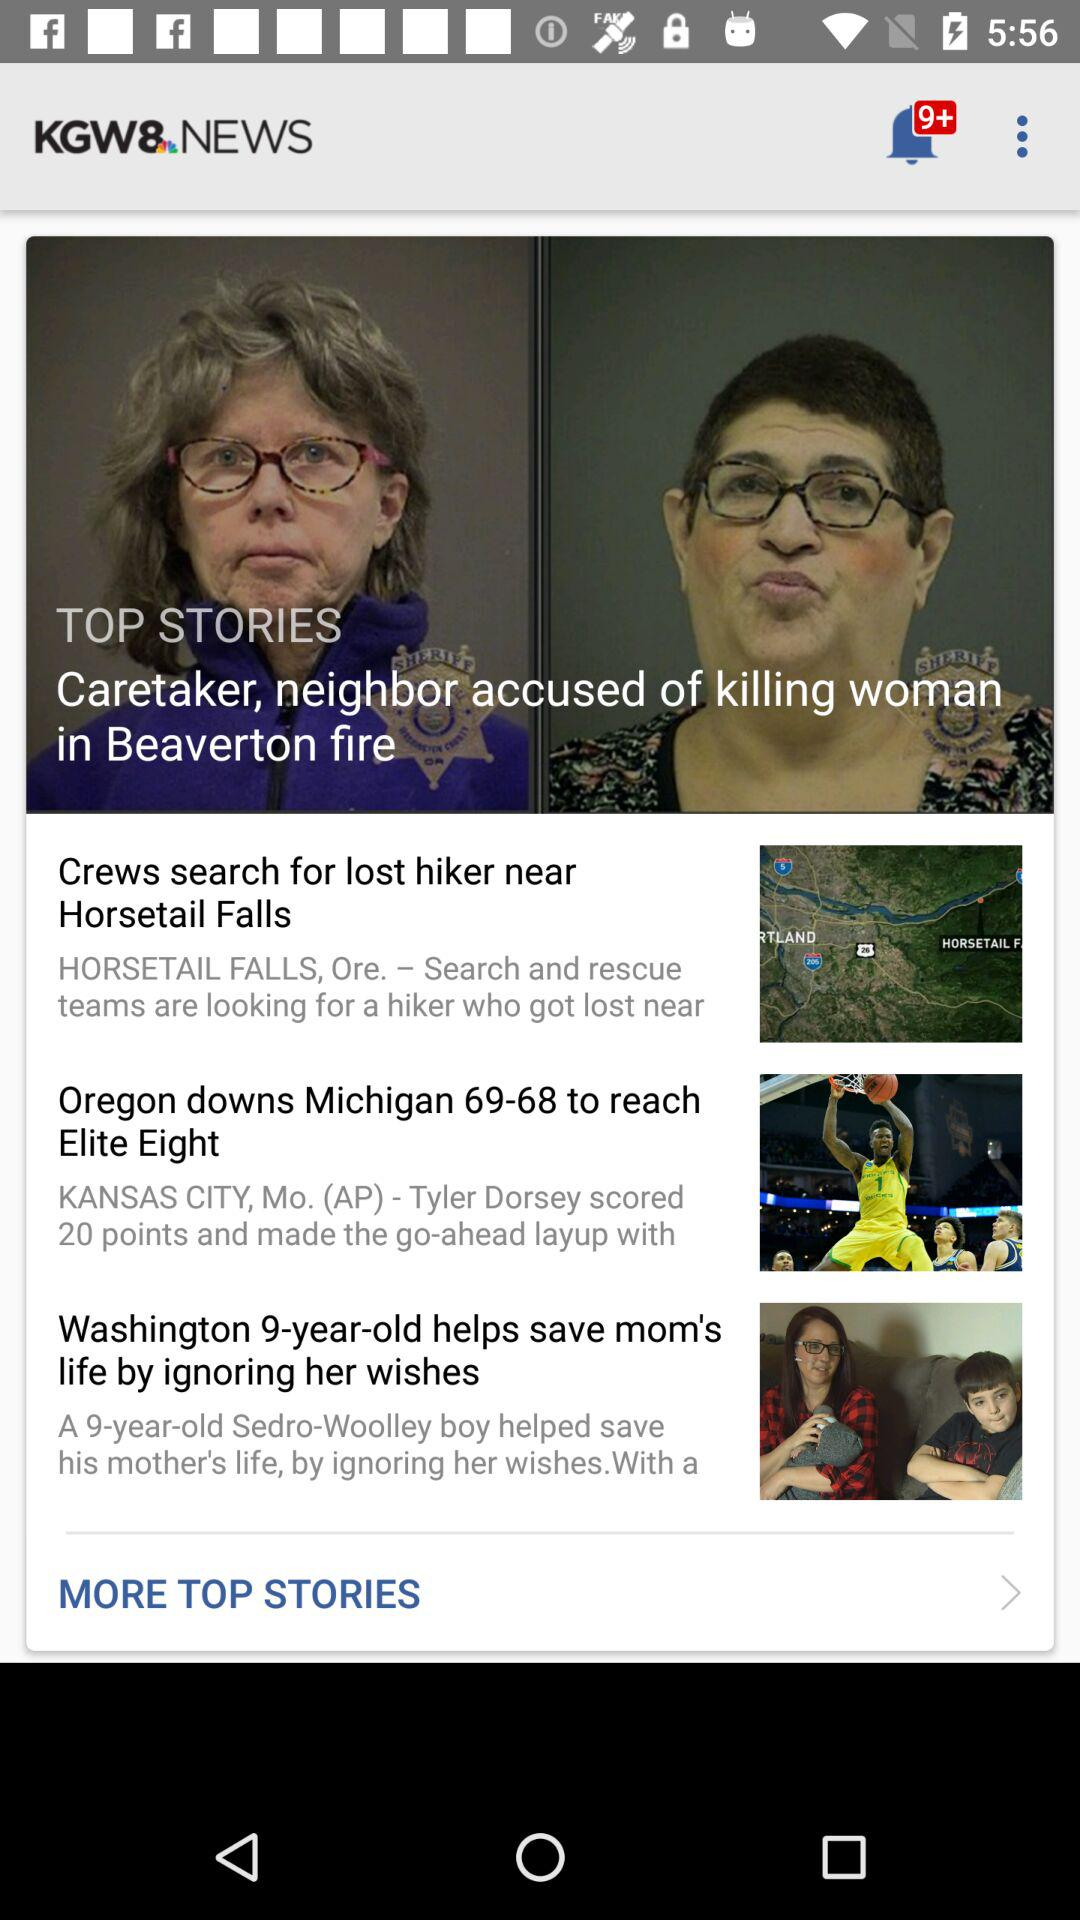What is the application name? The application name is "KGW8 NEWS". 